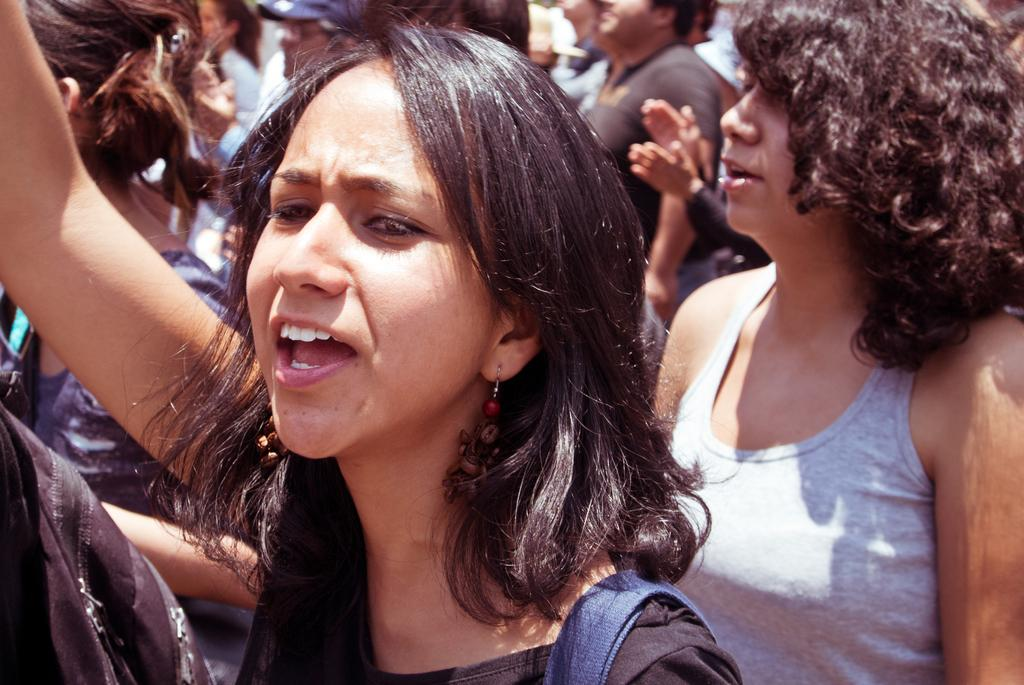How many women are in the foreground of the image? There are 2 women standing in the foreground of the image. What can be seen in the background of the image? There are multiple people in the background of the image. Can you describe the quality of the image? The top part of the image is blurry. What type of stem can be seen growing from the sheet in the image? There is no stem or sheet present in the image. 